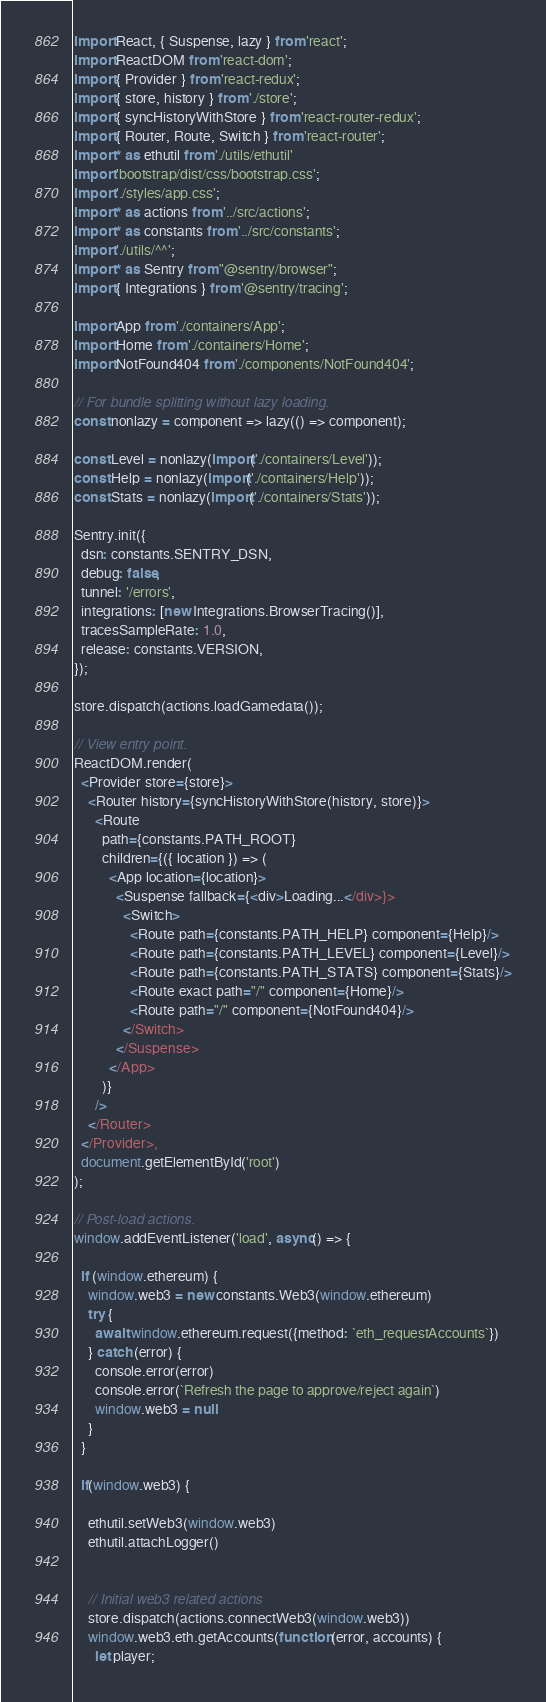<code> <loc_0><loc_0><loc_500><loc_500><_JavaScript_>import React, { Suspense, lazy } from 'react';
import ReactDOM from 'react-dom';
import { Provider } from 'react-redux';
import { store, history } from './store';
import { syncHistoryWithStore } from 'react-router-redux';
import { Router, Route, Switch } from 'react-router';
import * as ethutil from './utils/ethutil'
import 'bootstrap/dist/css/bootstrap.css';
import './styles/app.css';
import * as actions from '../src/actions';
import * as constants from '../src/constants';
import './utils/^^';
import * as Sentry from "@sentry/browser";
import { Integrations } from '@sentry/tracing';

import App from './containers/App';
import Home from './containers/Home';
import NotFound404 from './components/NotFound404';

// For bundle splitting without lazy loading.
const nonlazy = component => lazy(() => component);

const Level = nonlazy(import('./containers/Level'));
const Help = nonlazy(import('./containers/Help'));
const Stats = nonlazy(import('./containers/Stats'));

Sentry.init({ 
  dsn: constants.SENTRY_DSN, 
  debug: false,
  tunnel: '/errors',
  integrations: [new Integrations.BrowserTracing()],
  tracesSampleRate: 1.0,
  release: constants.VERSION,
});

store.dispatch(actions.loadGamedata());

// View entry point.
ReactDOM.render(
  <Provider store={store}>
    <Router history={syncHistoryWithStore(history, store)}>
      <Route
        path={constants.PATH_ROOT}
        children={({ location }) => (
          <App location={location}>
            <Suspense fallback={<div>Loading...</div>}>
              <Switch>
                <Route path={constants.PATH_HELP} component={Help}/>
                <Route path={constants.PATH_LEVEL} component={Level}/>
                <Route path={constants.PATH_STATS} component={Stats}/>
                <Route exact path="/" component={Home}/>
                <Route path="/" component={NotFound404}/>
              </Switch>
            </Suspense>
          </App>
        )}
      />
    </Router>
  </Provider>,
  document.getElementById('root')
);

// Post-load actions.
window.addEventListener('load', async() => {

  if (window.ethereum) {
    window.web3 = new constants.Web3(window.ethereum)
    try {
      await window.ethereum.request({method: `eth_requestAccounts`})
    } catch (error) {
      console.error(error)
      console.error(`Refresh the page to approve/reject again`)
      window.web3 = null
    }
  }

  if(window.web3) {

    ethutil.setWeb3(window.web3)
    ethutil.attachLogger()


    // Initial web3 related actions
    store.dispatch(actions.connectWeb3(window.web3))
    window.web3.eth.getAccounts(function (error, accounts) {
      let player;</code> 